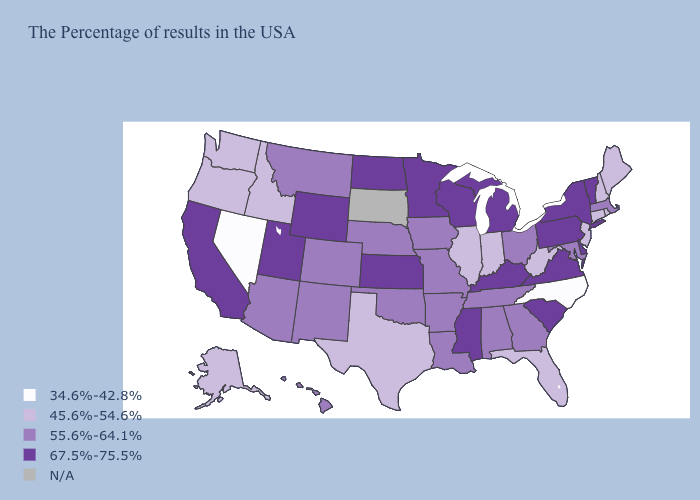Name the states that have a value in the range 67.5%-75.5%?
Write a very short answer. Vermont, New York, Delaware, Pennsylvania, Virginia, South Carolina, Michigan, Kentucky, Wisconsin, Mississippi, Minnesota, Kansas, North Dakota, Wyoming, Utah, California. Which states hav the highest value in the MidWest?
Keep it brief. Michigan, Wisconsin, Minnesota, Kansas, North Dakota. Name the states that have a value in the range 55.6%-64.1%?
Write a very short answer. Massachusetts, Maryland, Ohio, Georgia, Alabama, Tennessee, Louisiana, Missouri, Arkansas, Iowa, Nebraska, Oklahoma, Colorado, New Mexico, Montana, Arizona, Hawaii. Does the map have missing data?
Quick response, please. Yes. Does the first symbol in the legend represent the smallest category?
Short answer required. Yes. Which states have the lowest value in the South?
Quick response, please. North Carolina. Among the states that border Massachusetts , does New York have the highest value?
Quick response, please. Yes. Does Wisconsin have the lowest value in the USA?
Give a very brief answer. No. Among the states that border Maine , which have the highest value?
Short answer required. New Hampshire. Which states have the highest value in the USA?
Quick response, please. Vermont, New York, Delaware, Pennsylvania, Virginia, South Carolina, Michigan, Kentucky, Wisconsin, Mississippi, Minnesota, Kansas, North Dakota, Wyoming, Utah, California. How many symbols are there in the legend?
Be succinct. 5. Is the legend a continuous bar?
Be succinct. No. Which states have the highest value in the USA?
Answer briefly. Vermont, New York, Delaware, Pennsylvania, Virginia, South Carolina, Michigan, Kentucky, Wisconsin, Mississippi, Minnesota, Kansas, North Dakota, Wyoming, Utah, California. Among the states that border Rhode Island , does Massachusetts have the highest value?
Answer briefly. Yes. Name the states that have a value in the range N/A?
Quick response, please. South Dakota. 